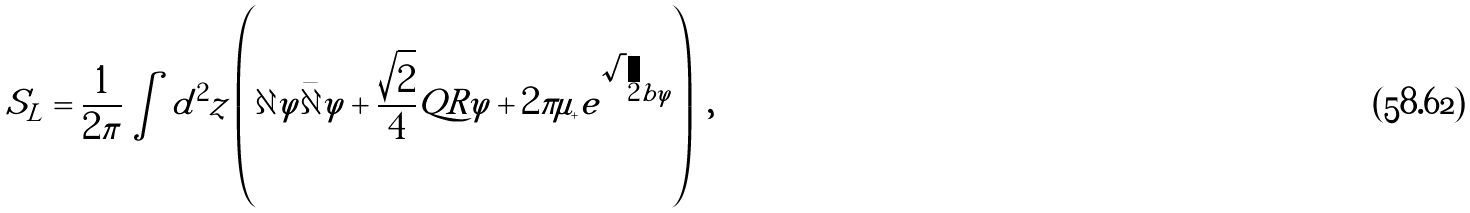<formula> <loc_0><loc_0><loc_500><loc_500>S _ { L } = \frac { 1 } { 2 \pi } \int d ^ { 2 } z \left ( \partial \varphi \bar { \partial } \varphi + \frac { \sqrt { 2 } } { 4 } Q R \varphi + 2 \pi \mu _ { + } e ^ { \sqrt { 2 } b \varphi } \right ) \ ,</formula> 